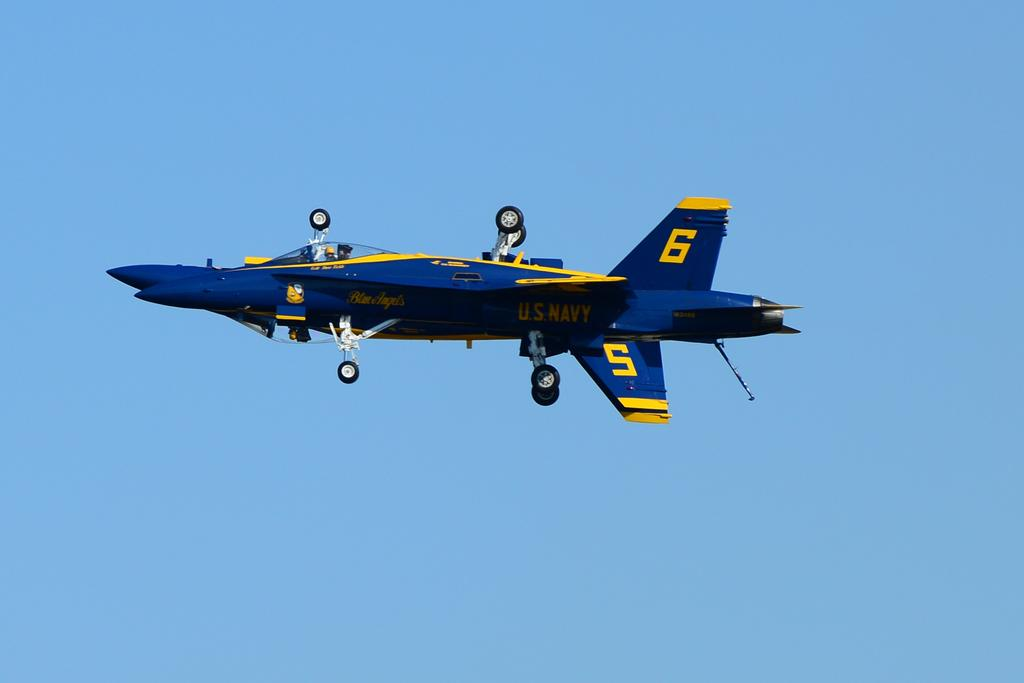<image>
Give a short and clear explanation of the subsequent image. A blue and yellow Navy plane has the numbers 5 and 6 on the tail. 